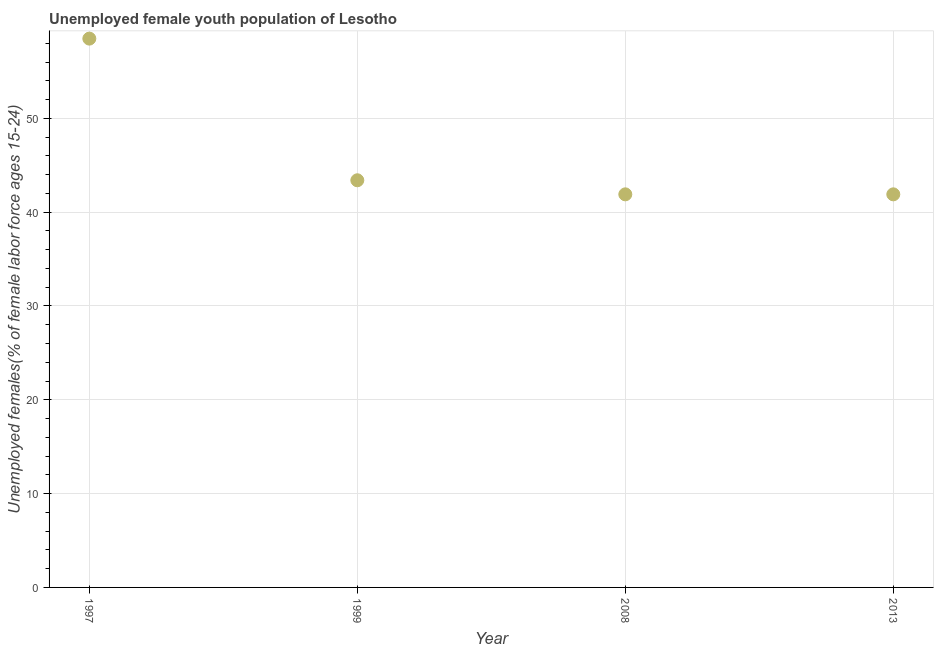What is the unemployed female youth in 1997?
Make the answer very short. 58.5. Across all years, what is the maximum unemployed female youth?
Make the answer very short. 58.5. Across all years, what is the minimum unemployed female youth?
Provide a succinct answer. 41.9. What is the sum of the unemployed female youth?
Your response must be concise. 185.7. What is the difference between the unemployed female youth in 1997 and 2008?
Provide a short and direct response. 16.6. What is the average unemployed female youth per year?
Offer a terse response. 46.43. What is the median unemployed female youth?
Provide a succinct answer. 42.65. Do a majority of the years between 1999 and 1997 (inclusive) have unemployed female youth greater than 30 %?
Your answer should be compact. No. What is the ratio of the unemployed female youth in 1999 to that in 2008?
Ensure brevity in your answer.  1.04. What is the difference between the highest and the second highest unemployed female youth?
Your answer should be very brief. 15.1. Is the sum of the unemployed female youth in 1999 and 2013 greater than the maximum unemployed female youth across all years?
Offer a terse response. Yes. What is the difference between the highest and the lowest unemployed female youth?
Provide a short and direct response. 16.6. How many dotlines are there?
Ensure brevity in your answer.  1. What is the difference between two consecutive major ticks on the Y-axis?
Your answer should be compact. 10. Does the graph contain any zero values?
Keep it short and to the point. No. Does the graph contain grids?
Ensure brevity in your answer.  Yes. What is the title of the graph?
Offer a terse response. Unemployed female youth population of Lesotho. What is the label or title of the X-axis?
Give a very brief answer. Year. What is the label or title of the Y-axis?
Your answer should be very brief. Unemployed females(% of female labor force ages 15-24). What is the Unemployed females(% of female labor force ages 15-24) in 1997?
Make the answer very short. 58.5. What is the Unemployed females(% of female labor force ages 15-24) in 1999?
Offer a terse response. 43.4. What is the Unemployed females(% of female labor force ages 15-24) in 2008?
Your response must be concise. 41.9. What is the Unemployed females(% of female labor force ages 15-24) in 2013?
Your answer should be very brief. 41.9. What is the difference between the Unemployed females(% of female labor force ages 15-24) in 1997 and 2008?
Give a very brief answer. 16.6. What is the difference between the Unemployed females(% of female labor force ages 15-24) in 1997 and 2013?
Your answer should be compact. 16.6. What is the difference between the Unemployed females(% of female labor force ages 15-24) in 1999 and 2013?
Provide a short and direct response. 1.5. What is the difference between the Unemployed females(% of female labor force ages 15-24) in 2008 and 2013?
Provide a short and direct response. 0. What is the ratio of the Unemployed females(% of female labor force ages 15-24) in 1997 to that in 1999?
Offer a very short reply. 1.35. What is the ratio of the Unemployed females(% of female labor force ages 15-24) in 1997 to that in 2008?
Your answer should be very brief. 1.4. What is the ratio of the Unemployed females(% of female labor force ages 15-24) in 1997 to that in 2013?
Give a very brief answer. 1.4. What is the ratio of the Unemployed females(% of female labor force ages 15-24) in 1999 to that in 2008?
Provide a succinct answer. 1.04. What is the ratio of the Unemployed females(% of female labor force ages 15-24) in 1999 to that in 2013?
Offer a very short reply. 1.04. What is the ratio of the Unemployed females(% of female labor force ages 15-24) in 2008 to that in 2013?
Ensure brevity in your answer.  1. 